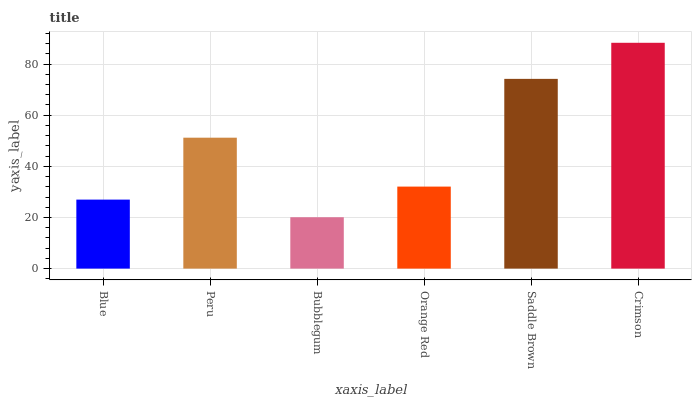Is Peru the minimum?
Answer yes or no. No. Is Peru the maximum?
Answer yes or no. No. Is Peru greater than Blue?
Answer yes or no. Yes. Is Blue less than Peru?
Answer yes or no. Yes. Is Blue greater than Peru?
Answer yes or no. No. Is Peru less than Blue?
Answer yes or no. No. Is Peru the high median?
Answer yes or no. Yes. Is Orange Red the low median?
Answer yes or no. Yes. Is Crimson the high median?
Answer yes or no. No. Is Bubblegum the low median?
Answer yes or no. No. 